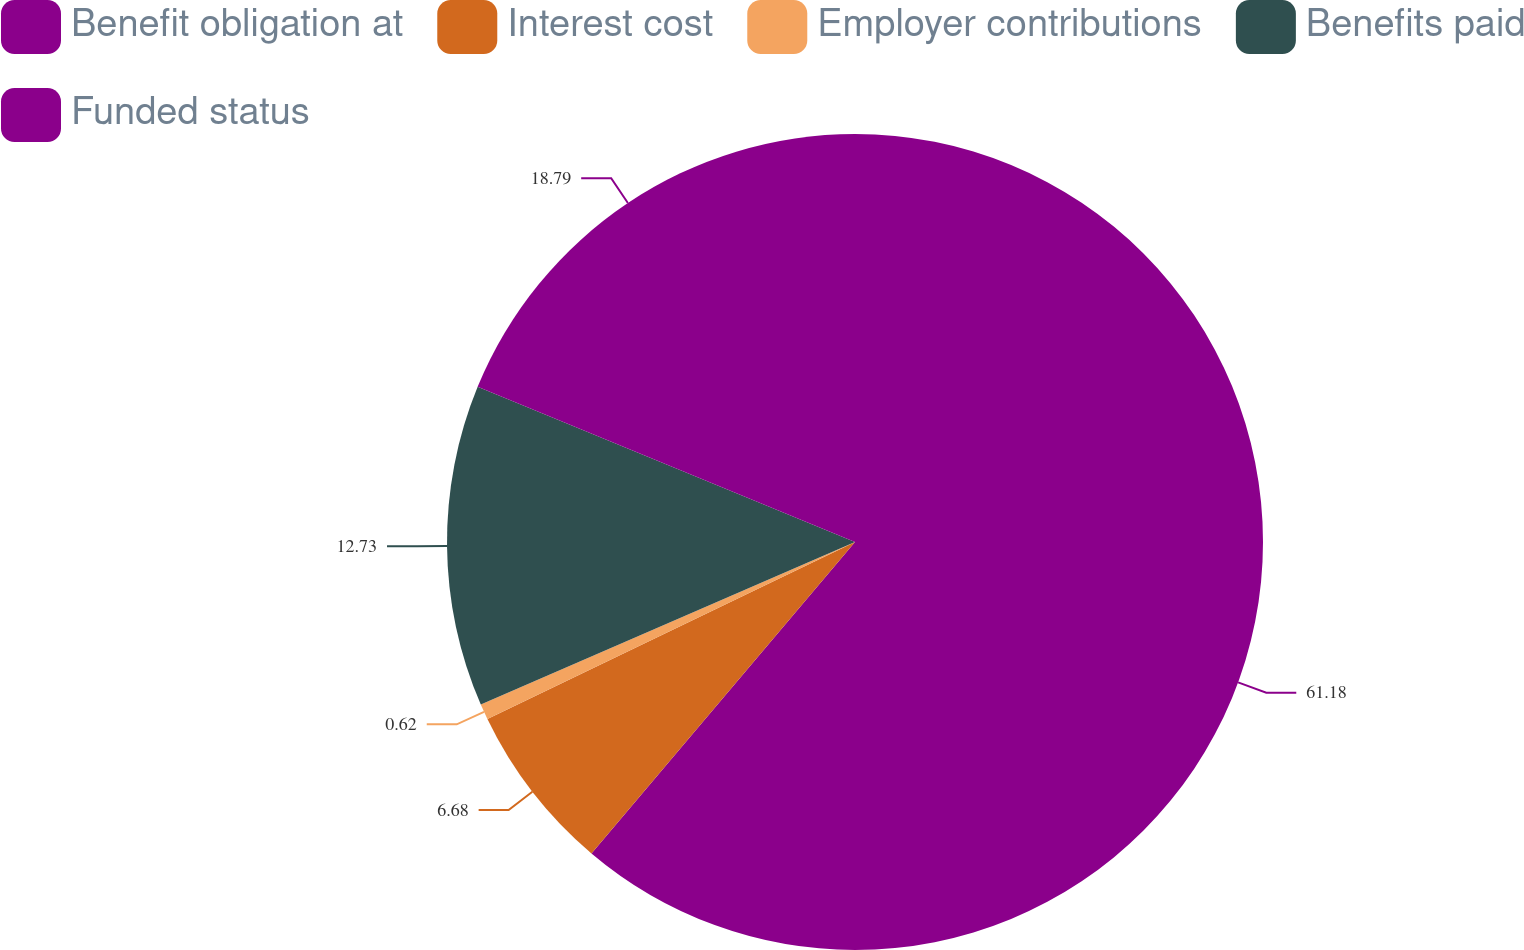<chart> <loc_0><loc_0><loc_500><loc_500><pie_chart><fcel>Benefit obligation at<fcel>Interest cost<fcel>Employer contributions<fcel>Benefits paid<fcel>Funded status<nl><fcel>61.17%<fcel>6.68%<fcel>0.62%<fcel>12.73%<fcel>18.79%<nl></chart> 